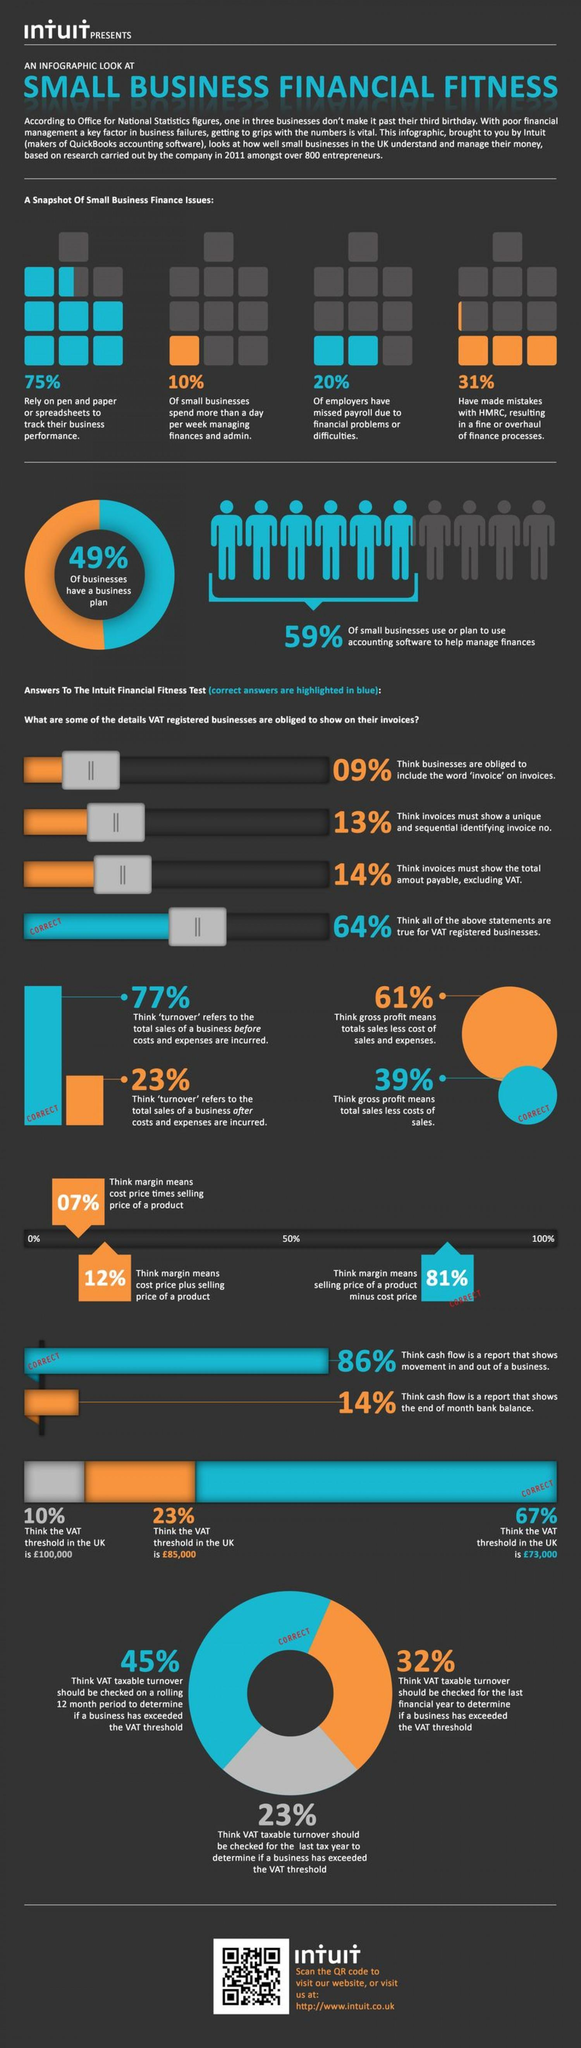What is the value of VAT threshold as believed by 67% of businesses in the UK?
Answer the question with a short phrase. €73,000 What percentage of businesses think that margin means selling price of a product minus cost price? 81% What percentage of small business do not rely on spreadsheets to track their business performance? 25% What percentage of businesses do not have a business plan according to the study conducted by a company in 2011? 51% What is the value of VAT threshold as believed by 23% of businesses in the UK? €85,000 What percentage of small business spend more than a day per week for managing finances & admin? 10% What percentage of businesses think that gross profit is the total sales less costs of sales? 39% What percentage of employers have missed payroll due to financial problems? 20% 